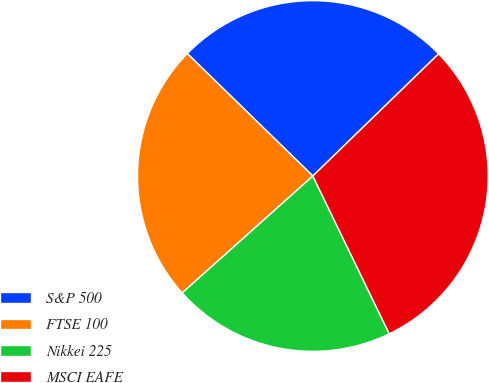Convert chart to OTSL. <chart><loc_0><loc_0><loc_500><loc_500><pie_chart><fcel>S&P 500<fcel>FTSE 100<fcel>Nikkei 225<fcel>MSCI EAFE<nl><fcel>25.43%<fcel>23.92%<fcel>20.56%<fcel>30.09%<nl></chart> 